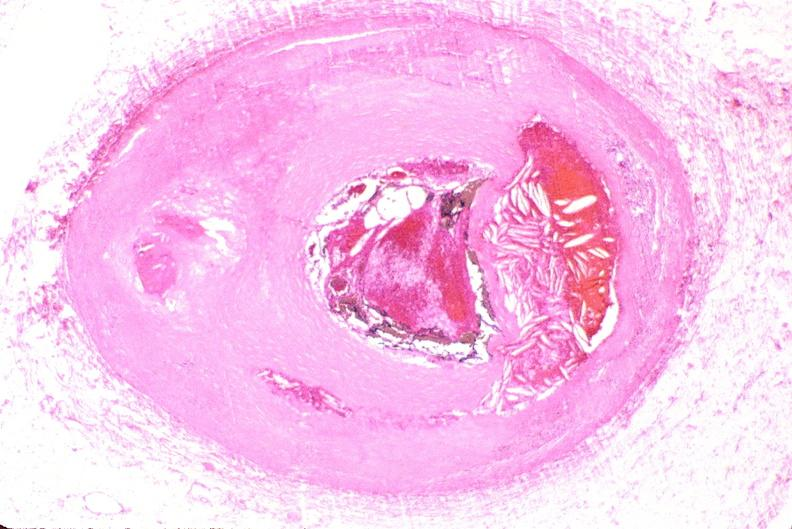what is present?
Answer the question using a single word or phrase. Cardiovascular 